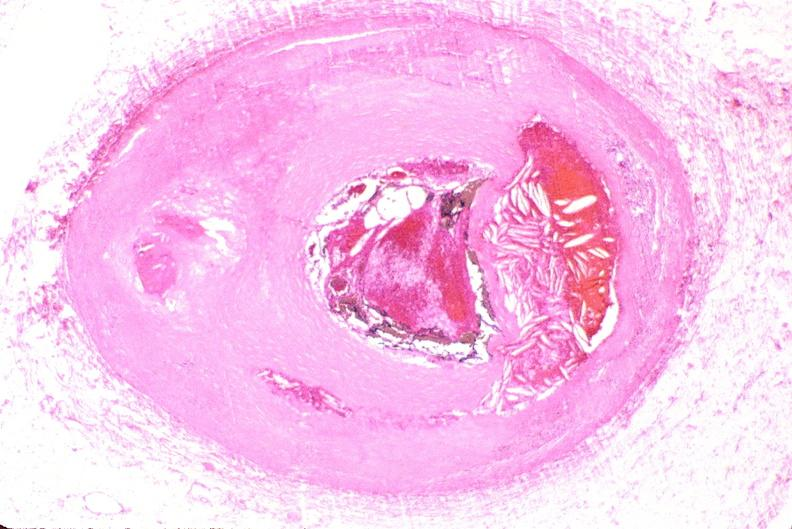what is present?
Answer the question using a single word or phrase. Cardiovascular 